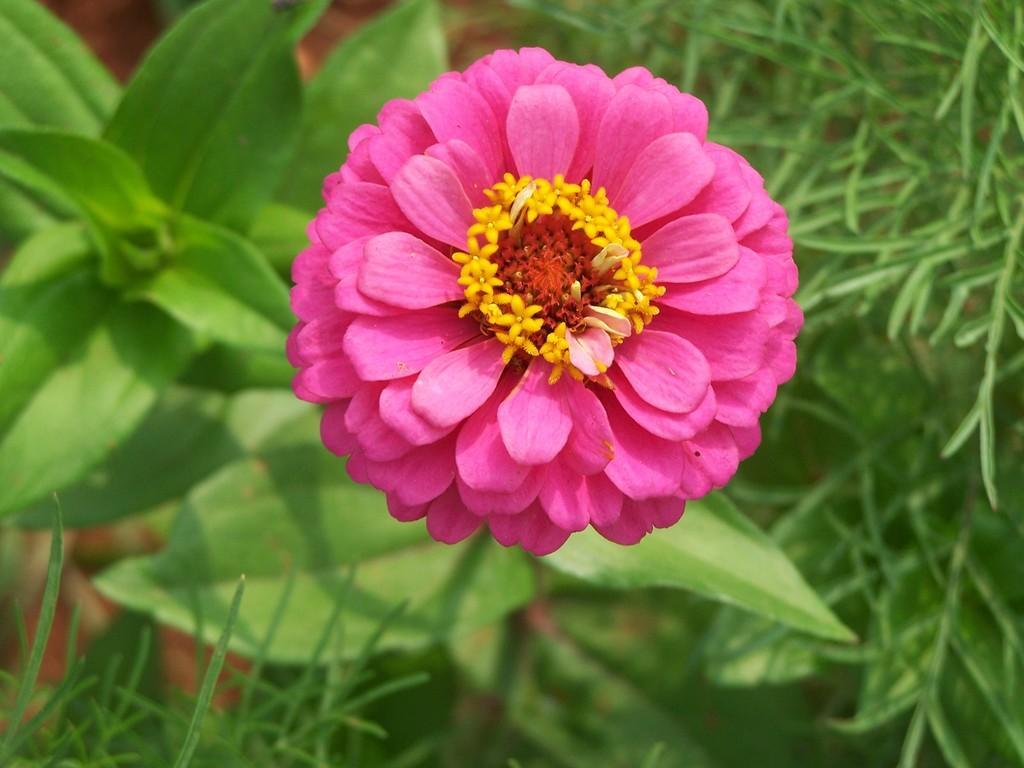Could you give a brief overview of what you see in this image? In the center of the image there is a flower to the plant. In the background there is grass. 